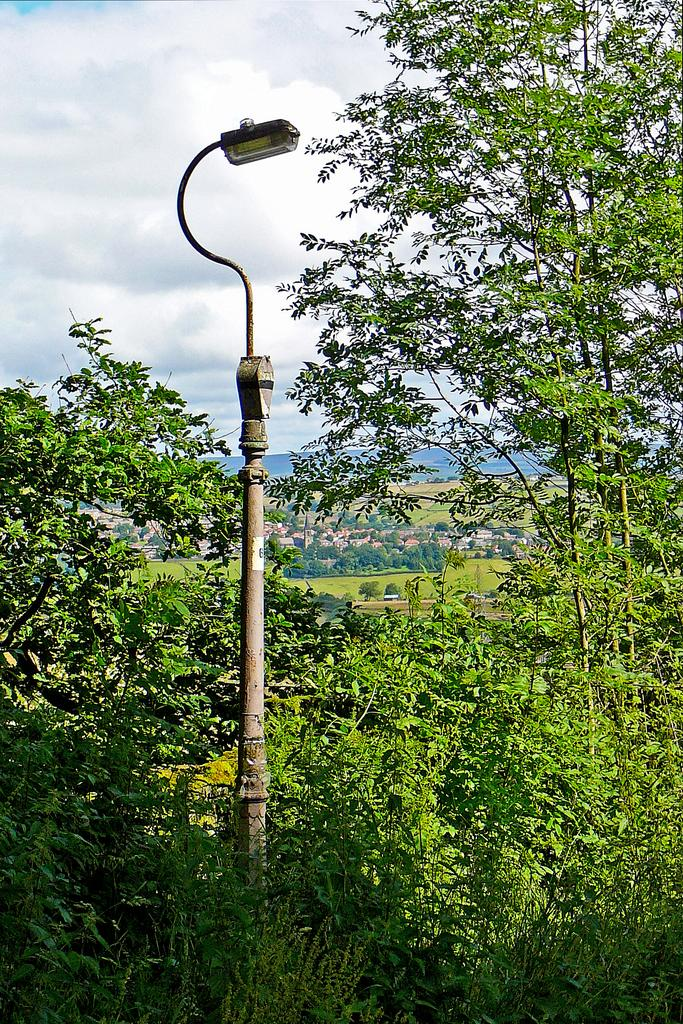What is the main object in the image? There is a pole in the image. What is attached to the pole? A light is present on the pole. What type of vegetation can be seen in the image? There are green color plants and trees in the image. What is visible in the background of the image? The sky is visible in the image. What is the condition of the sky in the image? The sky is cloudy in the image. What month is it in the image? The image does not provide any information about the month, so it cannot be determined from the image. Is there a letter addressed to someone in the image? There is no letter present in the image. 